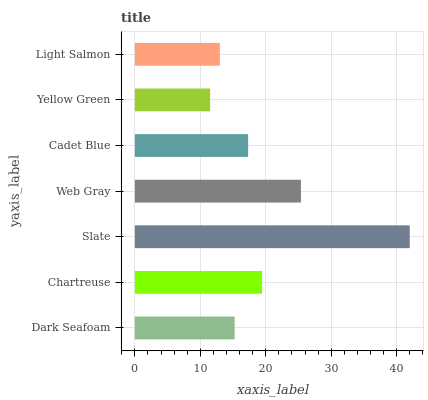Is Yellow Green the minimum?
Answer yes or no. Yes. Is Slate the maximum?
Answer yes or no. Yes. Is Chartreuse the minimum?
Answer yes or no. No. Is Chartreuse the maximum?
Answer yes or no. No. Is Chartreuse greater than Dark Seafoam?
Answer yes or no. Yes. Is Dark Seafoam less than Chartreuse?
Answer yes or no. Yes. Is Dark Seafoam greater than Chartreuse?
Answer yes or no. No. Is Chartreuse less than Dark Seafoam?
Answer yes or no. No. Is Cadet Blue the high median?
Answer yes or no. Yes. Is Cadet Blue the low median?
Answer yes or no. Yes. Is Light Salmon the high median?
Answer yes or no. No. Is Slate the low median?
Answer yes or no. No. 